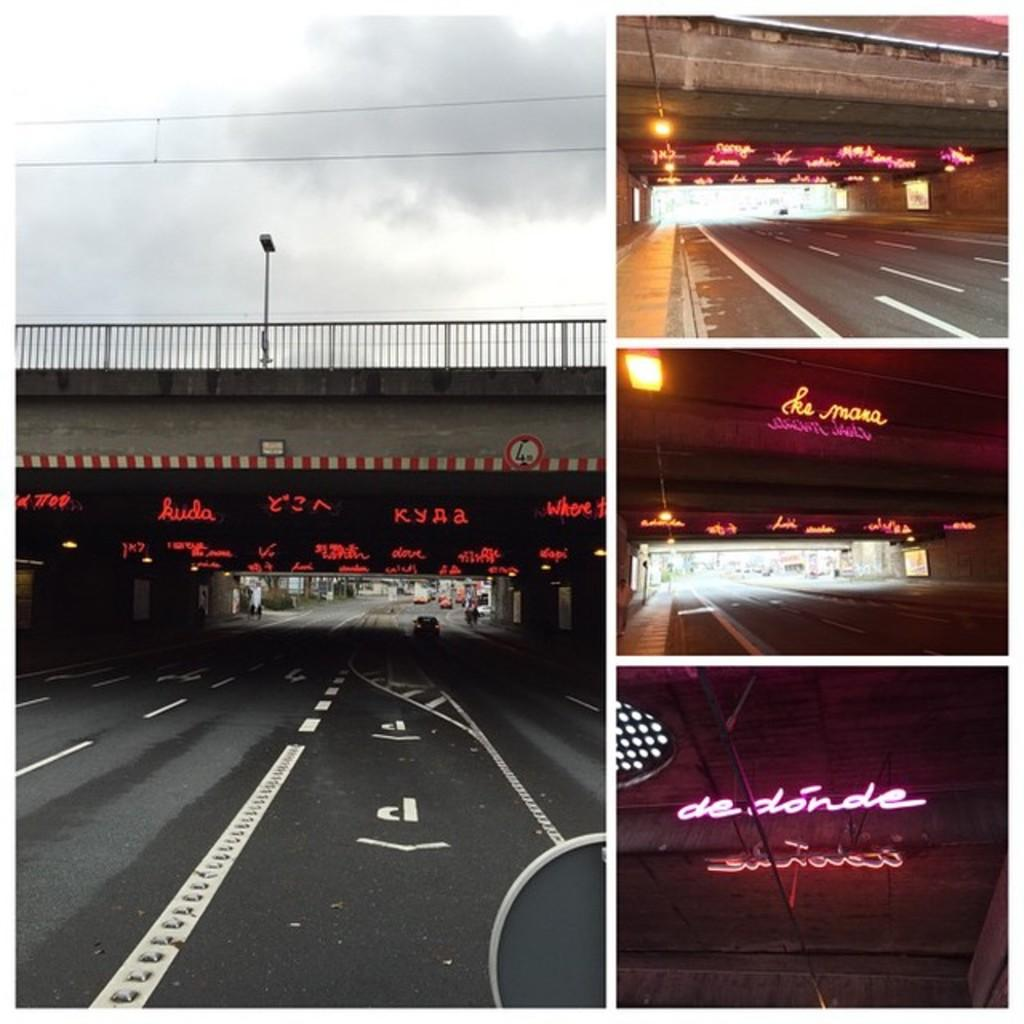What is the composition of the image? The image is a collage of four pictures. Can you describe one of the pictures in the collage? Yes, one of the pictures features a flyover. What is present in another picture in the collage? Another picture in the collage features a road. What can be seen in a third picture in the collage? In a third picture in the collage, there are vehicles visible. What type of committee is meeting in one of the pictures? There is no committee meeting present in any of the pictures in the collage. How many beds are visible in one of the pictures? There are no beds visible in any of the pictures in the collage. 